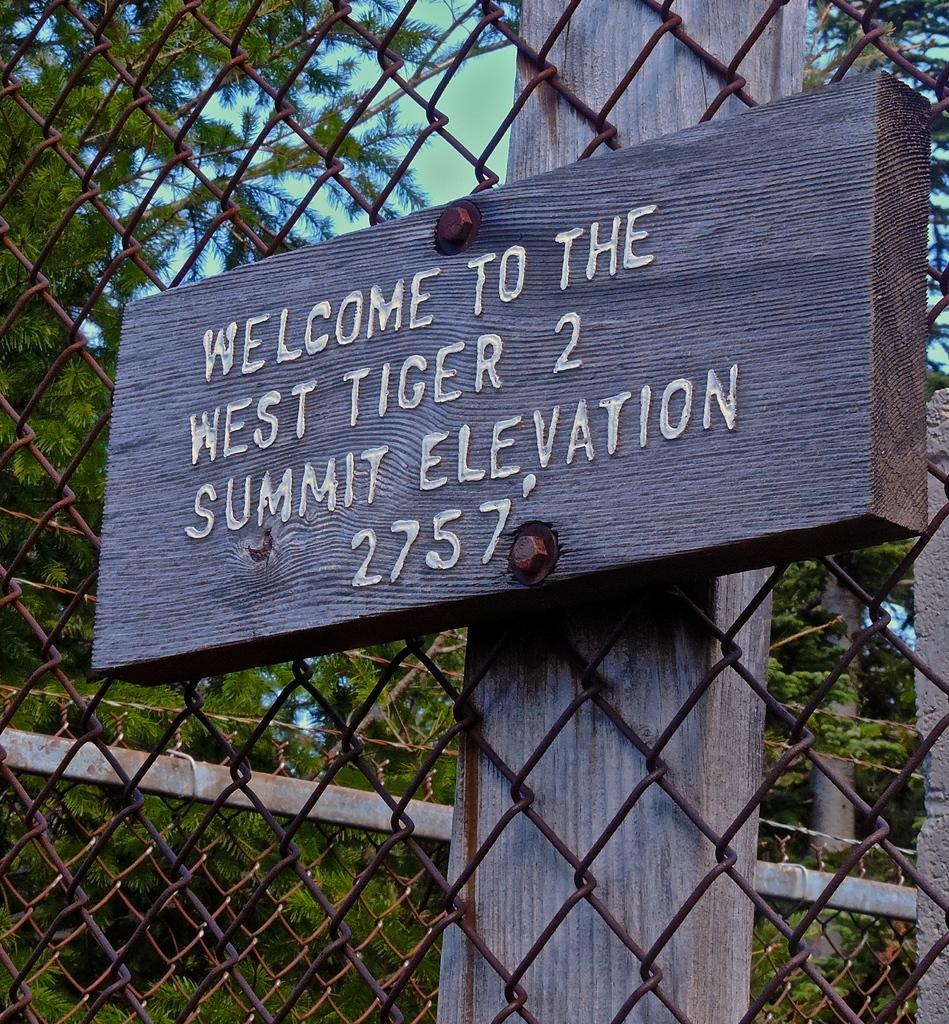Please provide a concise description of this image. This picture is clicked outside. In the foreground we can see the mesh and the text and numbers on the wooden board attached to the wooden plank. In the background we can see the plants, trees and the sky and some other objects. 